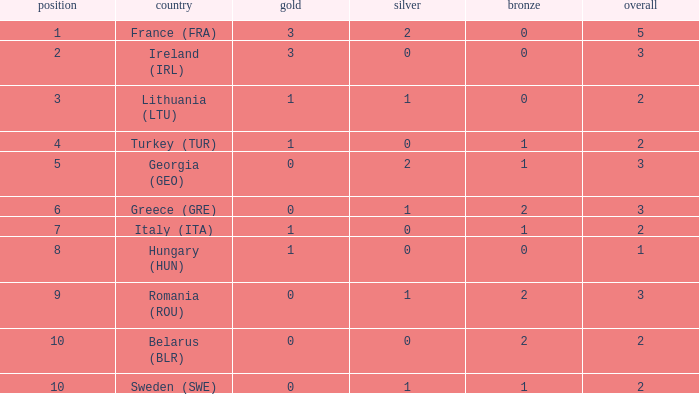What are the most bronze medals in a rank more than 1 with a total larger than 3? None. 